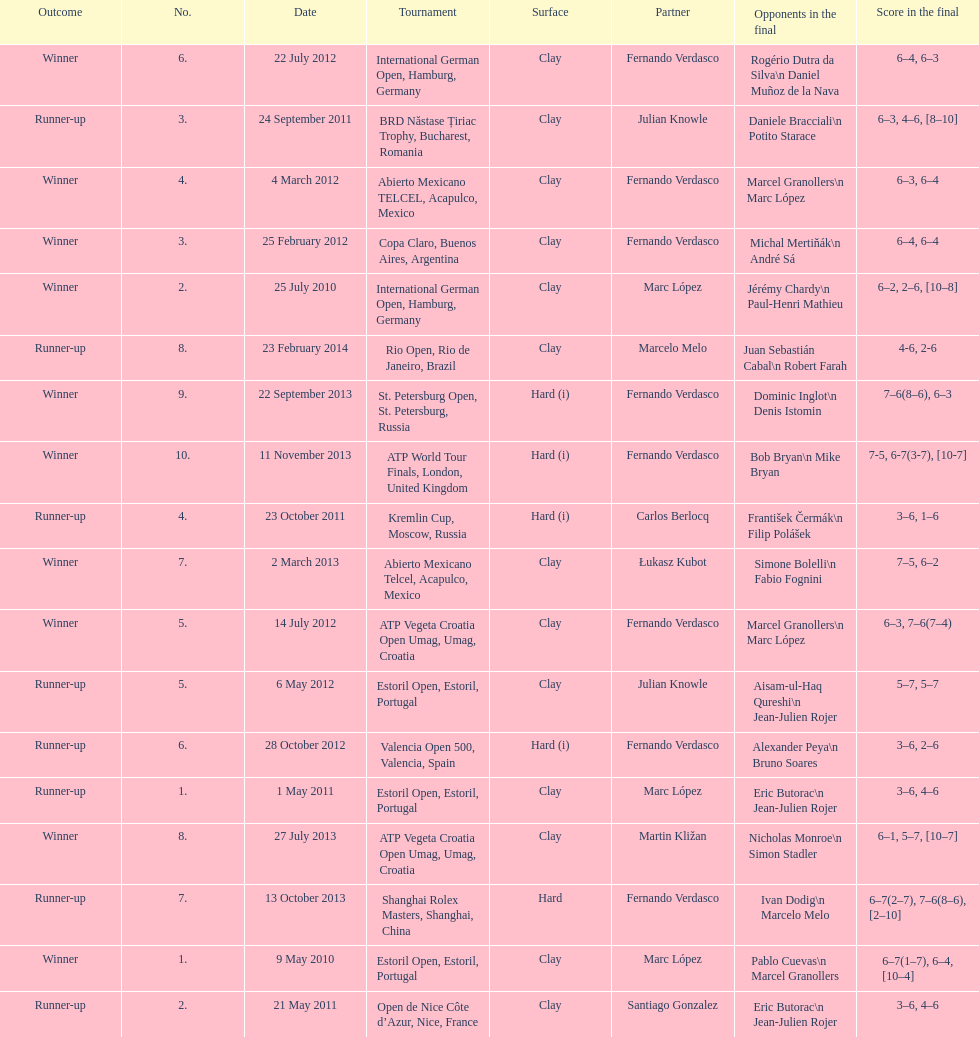What tournament was played after the kremlin cup? Copa Claro, Buenos Aires, Argentina. 